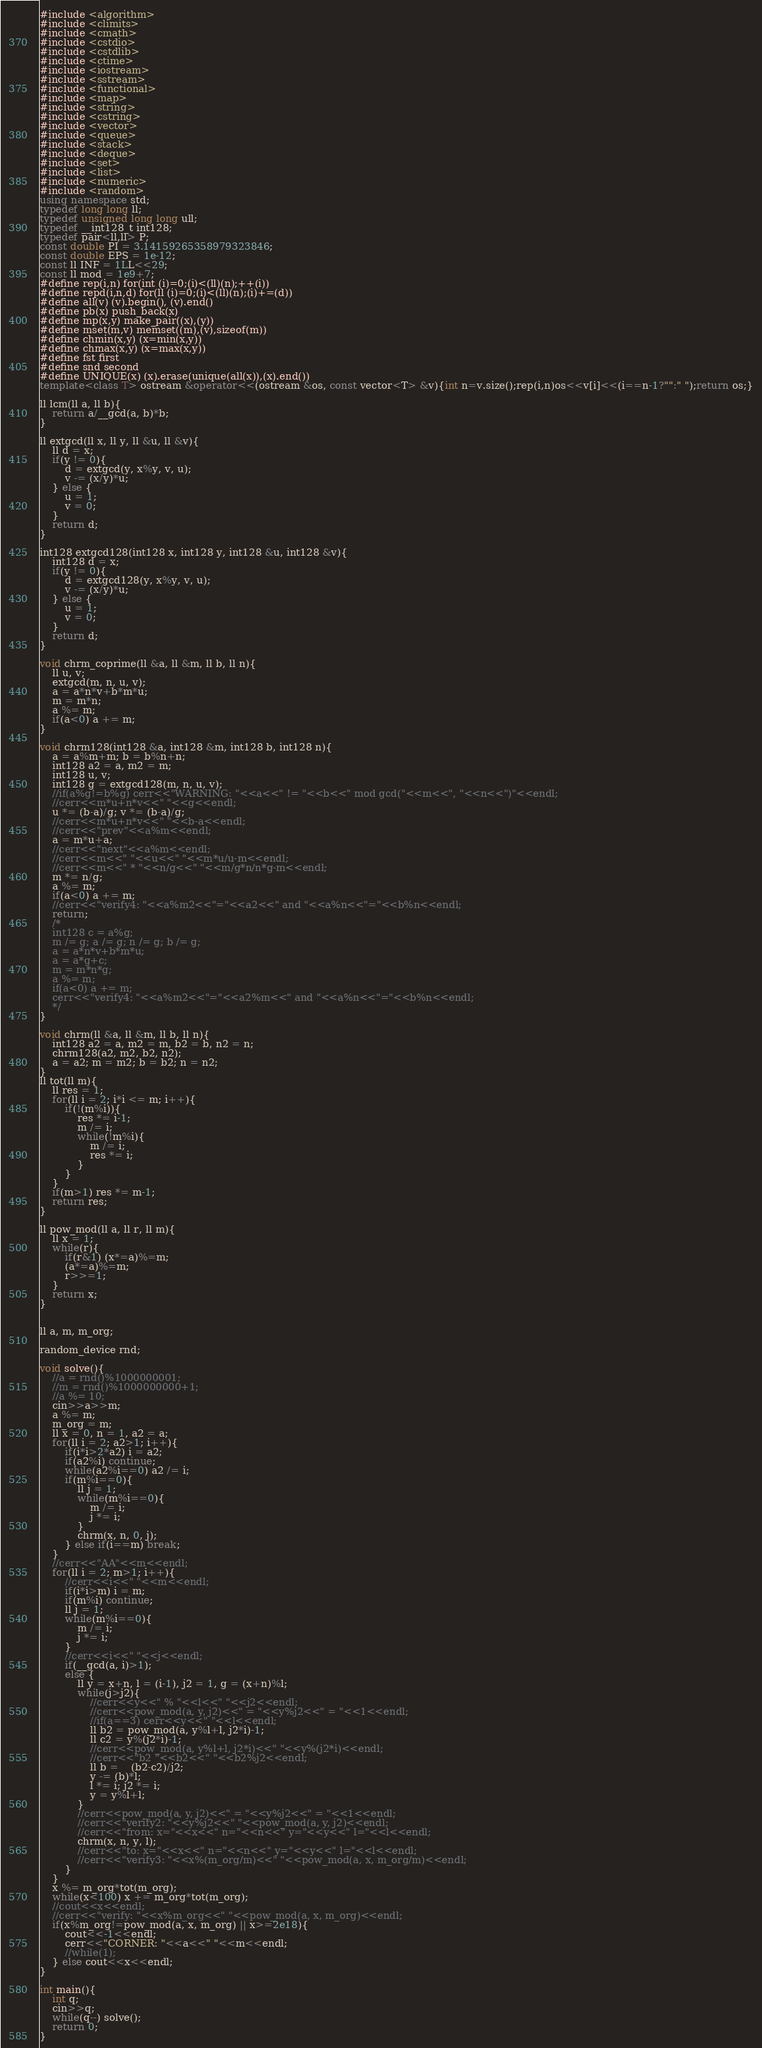Convert code to text. <code><loc_0><loc_0><loc_500><loc_500><_C++_>#include <algorithm>
#include <climits>
#include <cmath>
#include <cstdio>
#include <cstdlib>
#include <ctime>
#include <iostream>
#include <sstream>
#include <functional>
#include <map>
#include <string>
#include <cstring>
#include <vector>
#include <queue>
#include <stack>
#include <deque>
#include <set>
#include <list>
#include <numeric>
#include <random>
using namespace std;
typedef long long ll;
typedef unsigned long long ull;
typedef __int128_t int128;
typedef pair<ll,ll> P;
const double PI = 3.14159265358979323846;
const double EPS = 1e-12;
const ll INF = 1LL<<29;
const ll mod = 1e9+7;
#define rep(i,n) for(int (i)=0;(i)<(ll)(n);++(i))
#define repd(i,n,d) for(ll (i)=0;(i)<(ll)(n);(i)+=(d))
#define all(v) (v).begin(), (v).end()
#define pb(x) push_back(x)
#define mp(x,y) make_pair((x),(y))
#define mset(m,v) memset((m),(v),sizeof(m))
#define chmin(x,y) (x=min(x,y))
#define chmax(x,y) (x=max(x,y))
#define fst first
#define snd second
#define UNIQUE(x) (x).erase(unique(all(x)),(x).end())
template<class T> ostream &operator<<(ostream &os, const vector<T> &v){int n=v.size();rep(i,n)os<<v[i]<<(i==n-1?"":" ");return os;}

ll lcm(ll a, ll b){
    return a/__gcd(a, b)*b;
}

ll extgcd(ll x, ll y, ll &u, ll &v){
	ll d = x;
	if(y != 0){
		d = extgcd(y, x%y, v, u);
		v -= (x/y)*u;
	} else {
		u = 1;
		v = 0;
	}
	return d;
}

int128 extgcd128(int128 x, int128 y, int128 &u, int128 &v){
	int128 d = x;
	if(y != 0){
		d = extgcd128(y, x%y, v, u);
		v -= (x/y)*u;
	} else {
		u = 1;
		v = 0;
	}
	return d;
}

void chrm_coprime(ll &a, ll &m, ll b, ll n){
	ll u, v;
	extgcd(m, n, u, v);
	a = a*n*v+b*m*u;
	m = m*n;
	a %= m;
	if(a<0) a += m;
}

void chrm128(int128 &a, int128 &m, int128 b, int128 n){
	a = a%m+m; b = b%n+n;
	int128 a2 = a, m2 = m;
	int128 u, v;
	int128 g = extgcd128(m, n, u, v);
	//if(a%g!=b%g) cerr<<"WARNING: "<<a<<" != "<<b<<" mod gcd("<<m<<", "<<n<<")"<<endl;
	//cerr<<m*u+n*v<<" "<<g<<endl;
	u *= (b-a)/g; v *= (b-a)/g;
	//cerr<<m*u+n*v<<" "<<b-a<<endl;
	//cerr<<"prev"<<a%m<<endl;
	a = m*u+a;
	//cerr<<"next"<<a%m<<endl;
	//cerr<<m<<" "<<u<<" "<<m*u/u-m<<endl;
	//cerr<<m<<" * "<<n/g<<" "<<m/g*n/n*g-m<<endl;
	m *= n/g;
	a %= m;
	if(a<0) a += m;
	//cerr<<"verify4: "<<a%m2<<"="<<a2<<" and "<<a%n<<"="<<b%n<<endl;
	return;
	/*
	int128 c = a%g;
	m /= g; a /= g; n /= g; b /= g;
	a = a*n*v+b*m*u;
	a = a*g+c;
	m = m*n*g;
	a %= m;
	if(a<0) a += m;
	cerr<<"verify4: "<<a%m2<<"="<<a2%m<<" and "<<a%n<<"="<<b%n<<endl;
	*/
}

void chrm(ll &a, ll &m, ll b, ll n){
	int128 a2 = a, m2 = m, b2 = b, n2 = n;
	chrm128(a2, m2, b2, n2);
	a = a2; m = m2; b = b2; n = n2;
}
ll tot(ll m){
	ll res = 1;
	for(ll i = 2; i*i <= m; i++){
		if(!(m%i)){
			res *= i-1;
			m /= i;
			while(!m%i){
				m /= i;
				res *= i;
			}
		}
	}
	if(m>1) res *= m-1;
	return res;
}

ll pow_mod(ll a, ll r, ll m){
	ll x = 1;
	while(r){
		if(r&1) (x*=a)%=m;
		(a*=a)%=m;
		r>>=1;
	}
	return x;
}


ll a, m, m_org;

random_device rnd;

void solve(){
	//a = rnd()%1000000001;
	//m = rnd()%1000000000+1;
	//a %= 10;
	cin>>a>>m;
	a %= m;
	m_org = m;
	ll x = 0, n = 1, a2 = a;
	for(ll i = 2; a2>1; i++){
		if(i*i>2*a2) i = a2;
		if(a2%i) continue;
		while(a2%i==0) a2 /= i;
		if(m%i==0){
			ll j = 1;
			while(m%i==0){
				m /= i;
				j *= i;
			}
			chrm(x, n, 0, j);
		} else if(i==m) break;
	}
	//cerr<<"AA"<<m<<endl;
	for(ll i = 2; m>1; i++){
		//cerr<<i<<" "<<m<<endl;
		if(i*i>m) i = m;
		if(m%i) continue;
		ll j = 1;
		while(m%i==0){
			m /= i;
			j *= i;
		}
		//cerr<<i<<" "<<j<<endl;
		if(__gcd(a, i)>1);
		else {
			ll y = x+n, l = (i-1), j2 = 1, g = (x+n)%l;
			while(j>j2){
				//cerr<<y<<" % "<<l<<" "<<j2<<endl;
				//cerr<<pow_mod(a, y, j2)<<" = "<<y%j2<<" = "<<1<<endl;
				//if(a==3) cerr<<y<<" "<<l<<endl;
				ll b2 = pow_mod(a, y%l+l, j2*i)-1;
				ll c2 = y%(j2*i)-1;
				//cerr<<pow_mod(a, y%l+l, j2*i)<<" "<<y%(j2*i)<<endl;
				//cerr<<"b2 "<<b2<<" "<<b2%j2<<endl;
				ll b = 	(b2-c2)/j2;
				y -= (b)*l;
				l *= i; j2 *= i;
				y = y%l+l;
			}
			//cerr<<pow_mod(a, y, j2)<<" = "<<y%j2<<" = "<<1<<endl;
			//cerr<<"verify2: "<<y%j2<<" "<<pow_mod(a, y, j2)<<endl;
			//cerr<<"from: x="<<x<<" n="<<n<<" y="<<y<<" l="<<l<<endl;
			chrm(x, n, y, l);
			//cerr<<"to: x="<<x<<" n="<<n<<" y="<<y<<" l="<<l<<endl;
			//cerr<<"verify3: "<<x%(m_org/m)<<" "<<pow_mod(a, x, m_org/m)<<endl;
		}
	}
	x %= m_org*tot(m_org);
	while(x<100) x += m_org*tot(m_org);
	//cout<<x<<endl;
	//cerr<<"verify: "<<x%m_org<<" "<<pow_mod(a, x, m_org)<<endl;
	if(x%m_org!=pow_mod(a, x, m_org) || x>=2e18){
		cout<<-1<<endl;
		cerr<<"CORNER: "<<a<<" "<<m<<endl;
		//while(1);
	} else cout<<x<<endl;
}

int main(){
	int q;
	cin>>q;
	while(q--) solve();
	return 0;
}
</code> 